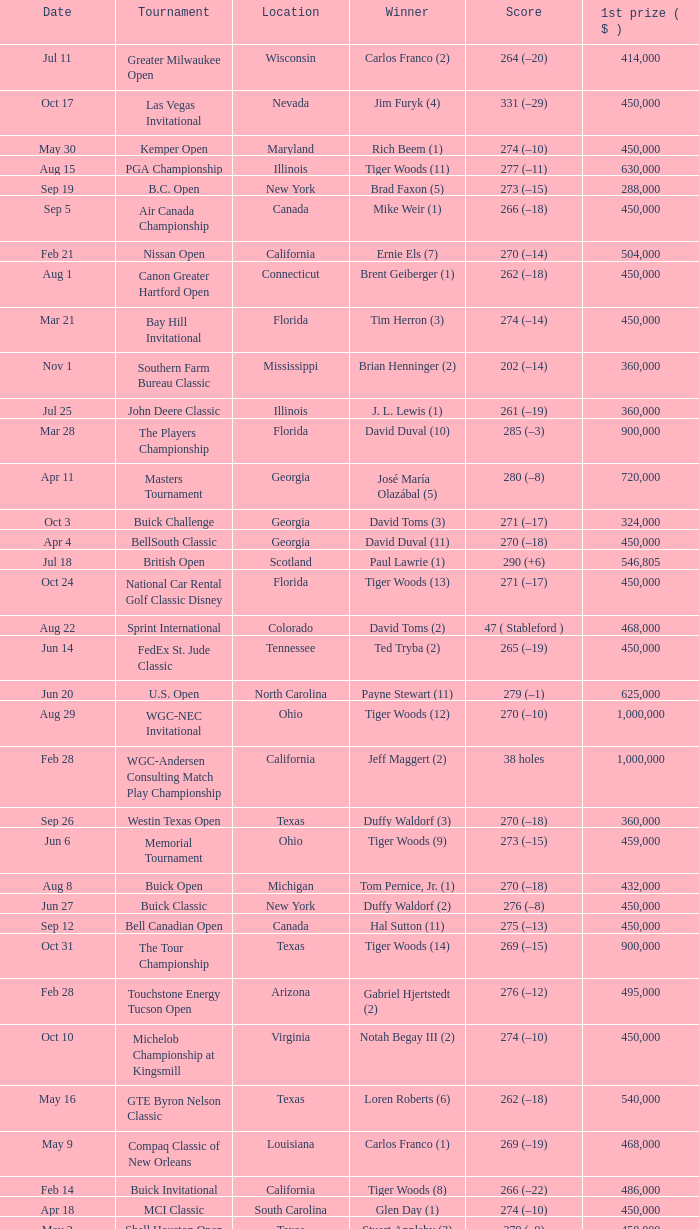What is the date of the Greater Greensboro Chrysler Classic? Apr 25. 